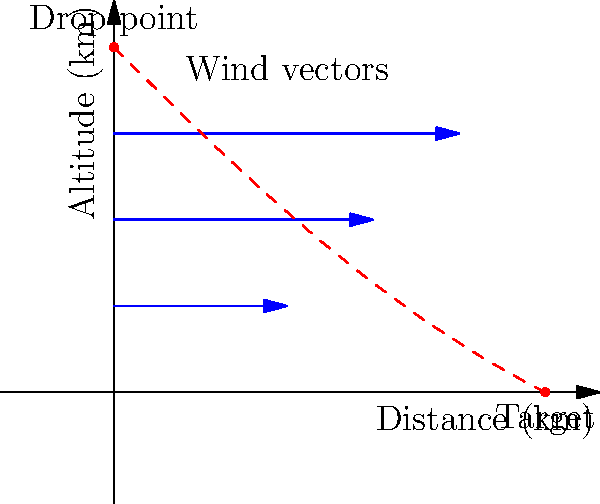Given the wind vector diagram showing wind speeds at different altitudes, what is the most efficient vector for air-dropping supplies to reach the target 5 km away? Consider that the aircraft is flying at an altitude of 4 km. To determine the most efficient vector for air-dropping supplies, we need to consider the following steps:

1. Analyze the wind vectors:
   - At 3 km altitude: 4 km/h eastward
   - At 2 km altitude: 3 km/h eastward
   - At 1 km altitude: 2 km/h eastward

2. Calculate the average wind speed:
   $\text{Average wind speed} = \frac{4 + 3 + 2}{3} = 3$ km/h eastward

3. Determine the time of fall:
   Using the equation of motion $s = \frac{1}{2}gt^2$, where $s = 4$ km and $g = 9.8$ m/s^2
   $4000 = \frac{1}{2} \times 9.8 \times t^2$
   $t = \sqrt{\frac{8000}{9.8}} \approx 28.57$ seconds

4. Calculate the horizontal distance covered by wind:
   $\text{Distance} = \text{Speed} \times \text{Time}$
   $\text{Distance} = 3 \times \frac{28.57}{3600} \approx 0.024$ km

5. Determine the drop point:
   The supplies should be dropped 0.024 km before the target.
   $\text{Drop point} = 5 - 0.024 = 4.976$ km from the starting point

6. Calculate the vector:
   The vector from the aircraft to the drop point is:
   $\vec{v} = (4.976 - 0)\hat{i} + (0 - 4)\hat{j} = 4.976\hat{i} - 4\hat{j}$

7. Normalize the vector:
   $|\vec{v}| = \sqrt{4.976^2 + 4^2} \approx 6.37$
   $\hat{v} = \frac{4.976}{6.37}\hat{i} - \frac{4}{6.37}\hat{j} \approx 0.781\hat{i} - 0.628\hat{j}$
Answer: $0.781\hat{i} - 0.628\hat{j}$ 